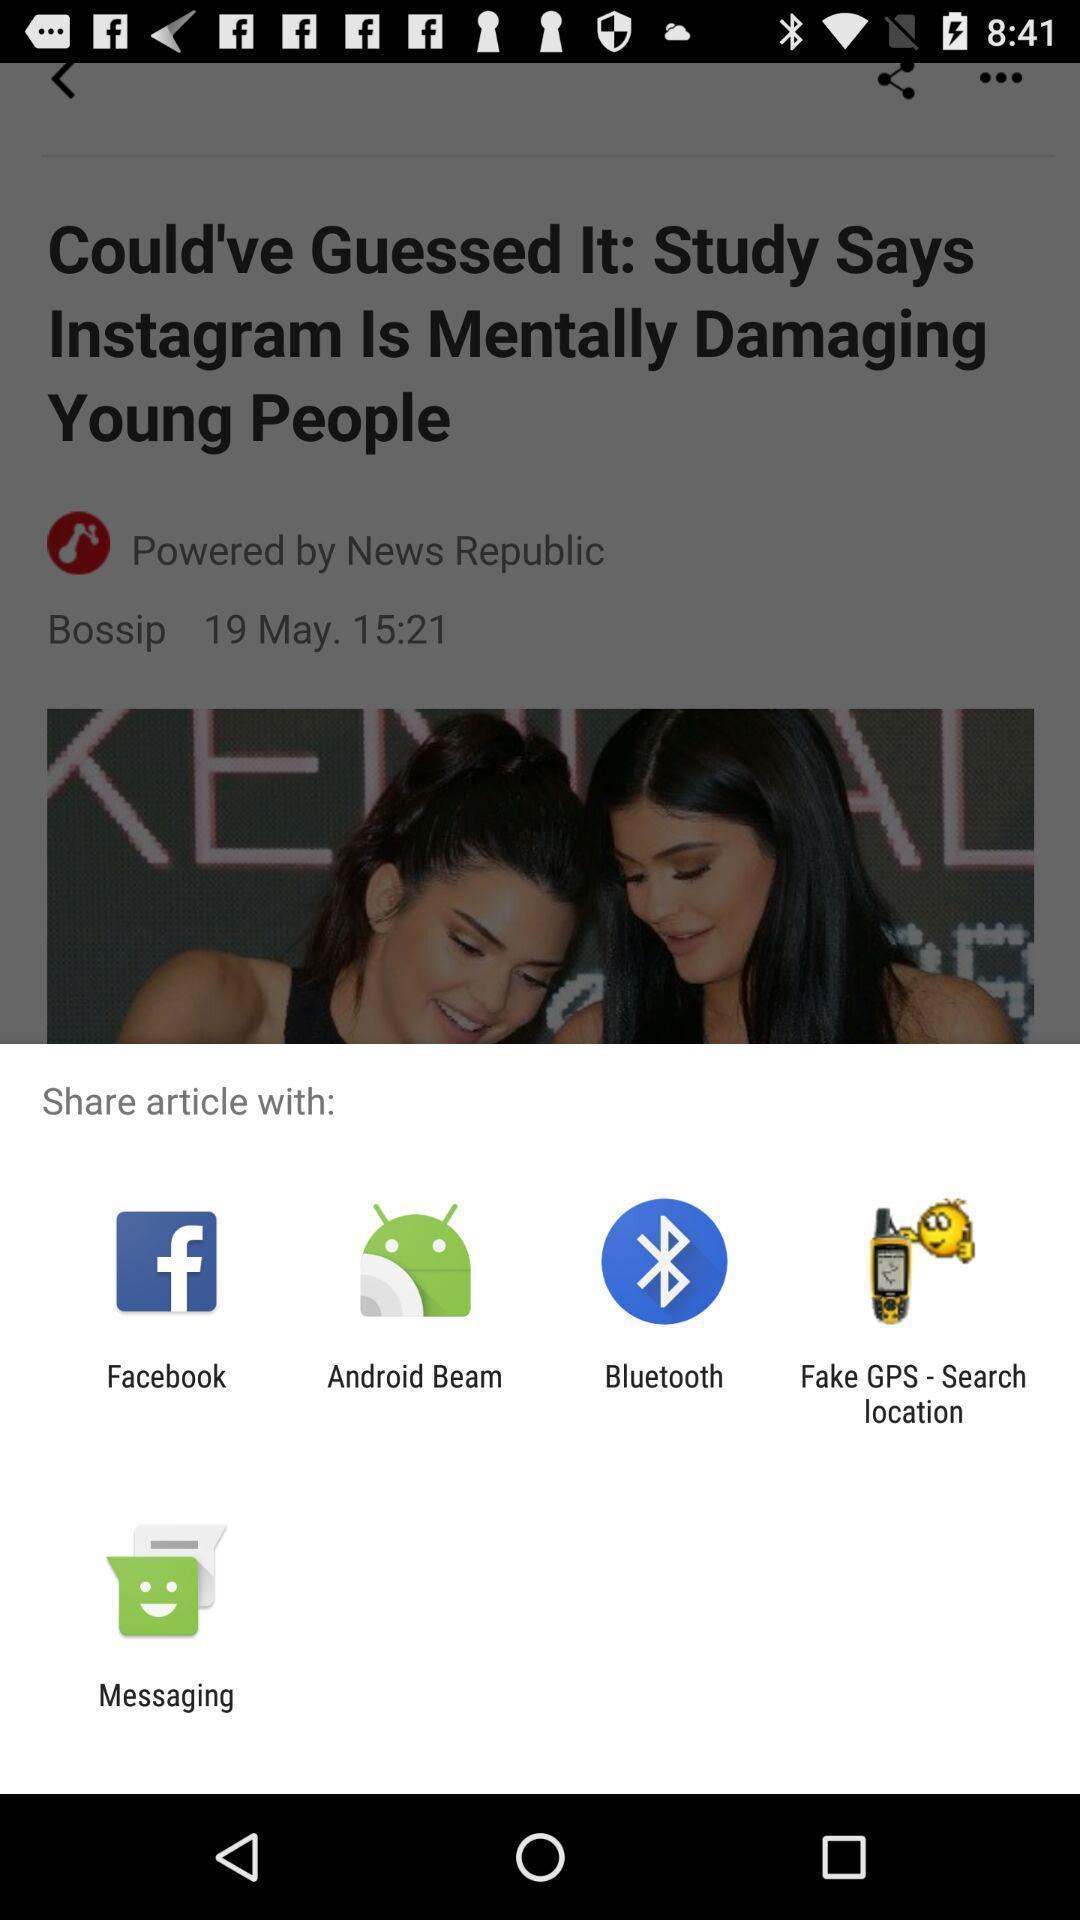Summarize the information in this screenshot. Popup displaying applications to share article. 